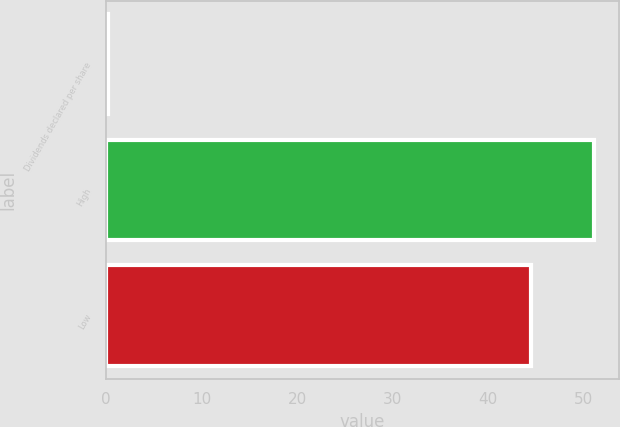Convert chart to OTSL. <chart><loc_0><loc_0><loc_500><loc_500><bar_chart><fcel>Dividends declared per share<fcel>High<fcel>Low<nl><fcel>0.21<fcel>51.13<fcel>44.56<nl></chart> 